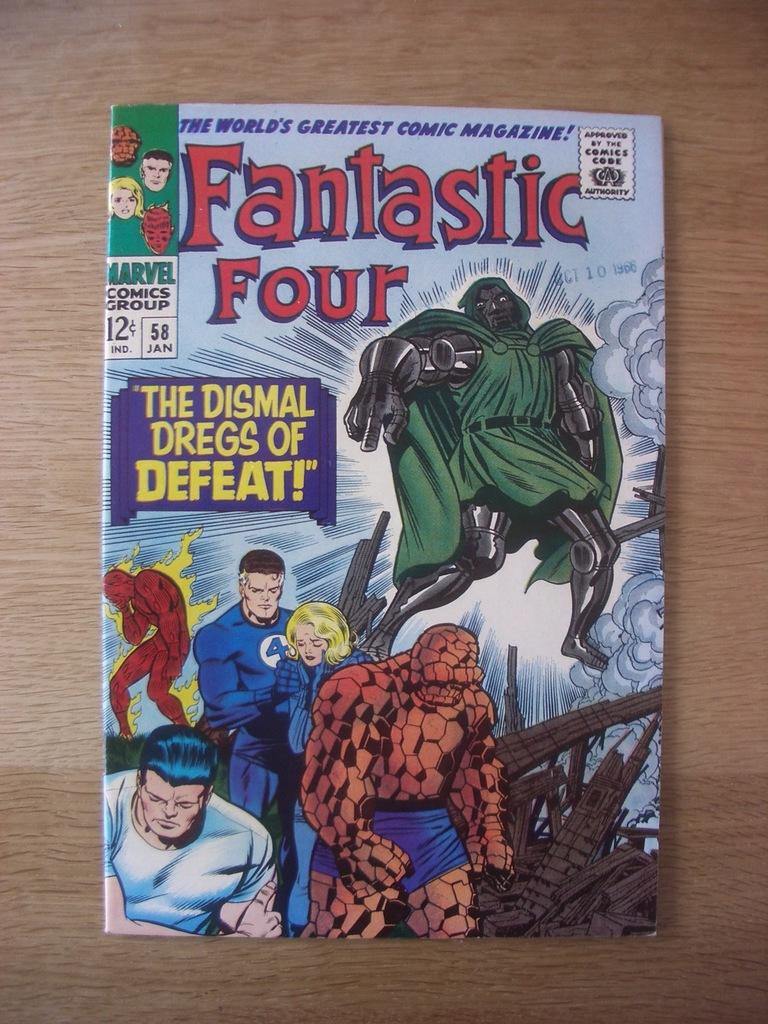What superhero group is focused on in this comic?
Offer a terse response. Fantastic four. How much was this comic book?
Give a very brief answer. 12 cents. 